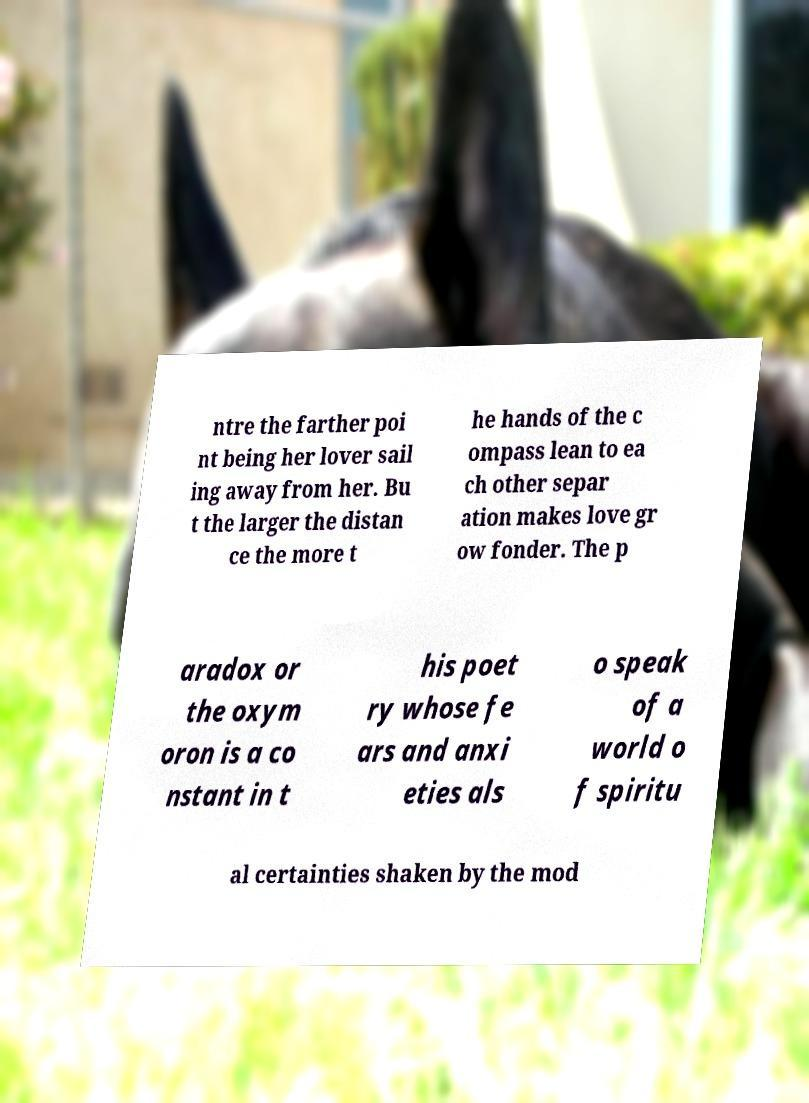Please identify and transcribe the text found in this image. ntre the farther poi nt being her lover sail ing away from her. Bu t the larger the distan ce the more t he hands of the c ompass lean to ea ch other separ ation makes love gr ow fonder. The p aradox or the oxym oron is a co nstant in t his poet ry whose fe ars and anxi eties als o speak of a world o f spiritu al certainties shaken by the mod 